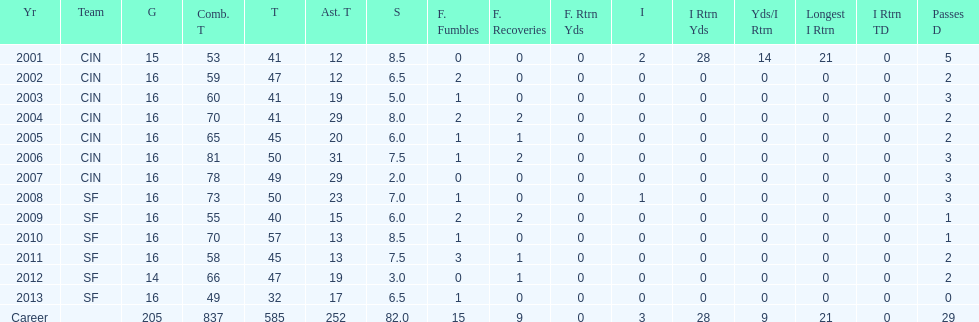How many consecutive seasons has he played sixteen games? 10. 